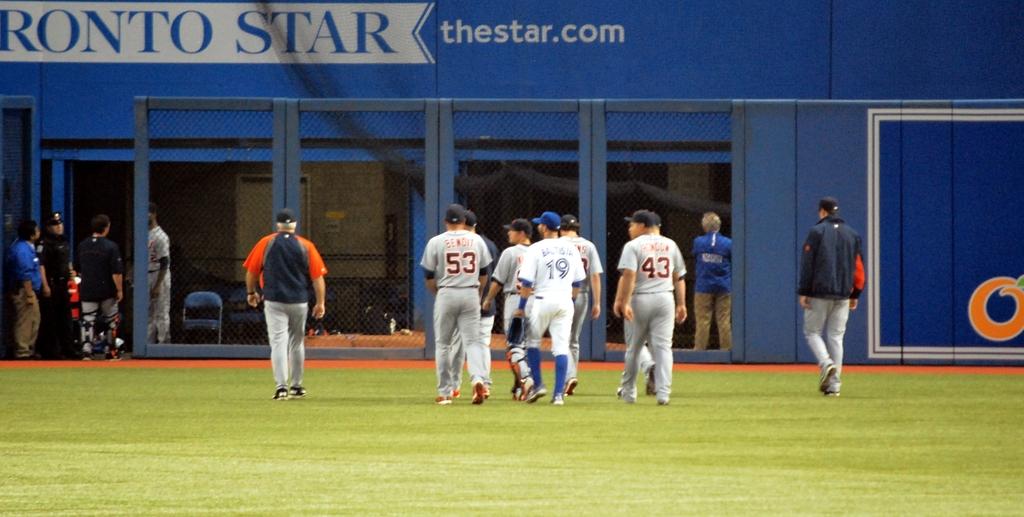Who is sponsoring the baseball stadium?
Your answer should be compact. Thestar.com. Whats the web site for the field?
Your answer should be compact. Thestar.com. 